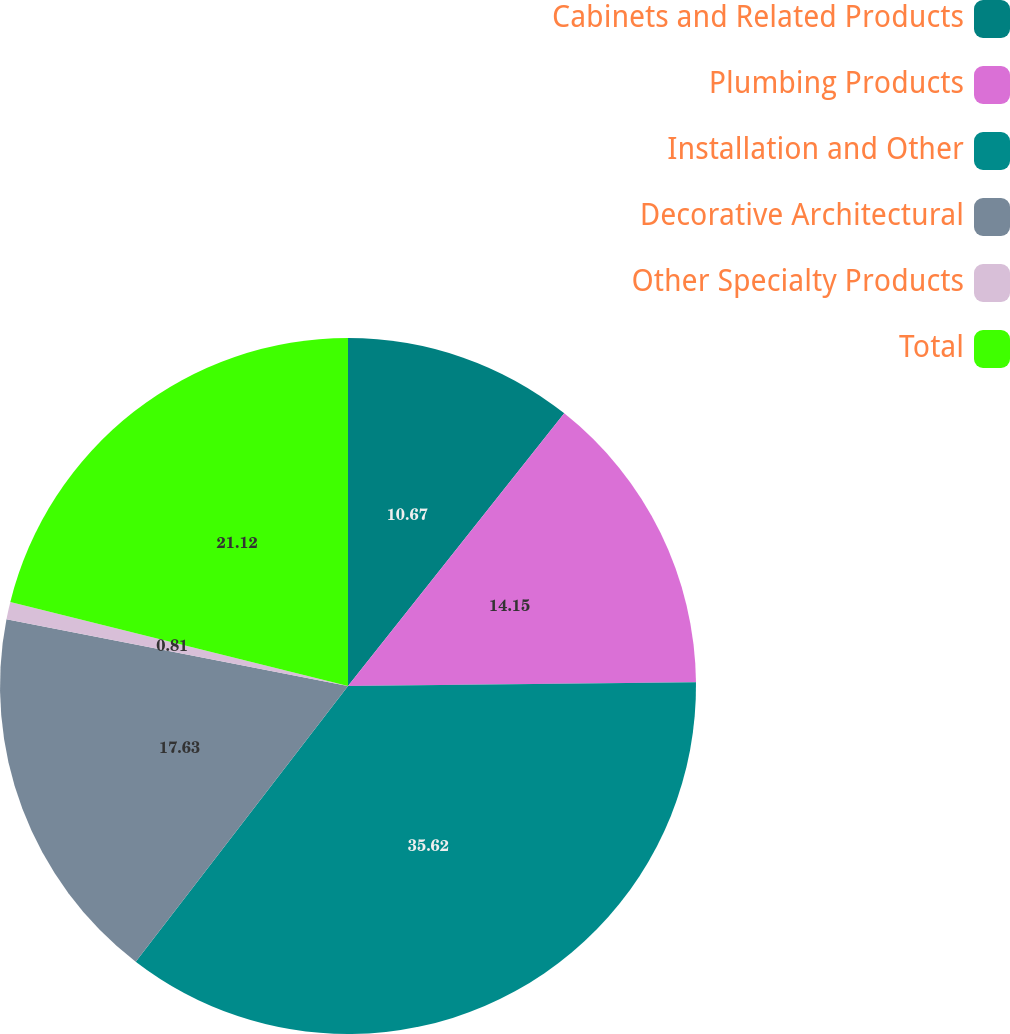Convert chart to OTSL. <chart><loc_0><loc_0><loc_500><loc_500><pie_chart><fcel>Cabinets and Related Products<fcel>Plumbing Products<fcel>Installation and Other<fcel>Decorative Architectural<fcel>Other Specialty Products<fcel>Total<nl><fcel>10.67%<fcel>14.15%<fcel>35.61%<fcel>17.63%<fcel>0.81%<fcel>21.11%<nl></chart> 